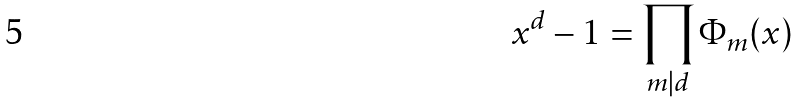Convert formula to latex. <formula><loc_0><loc_0><loc_500><loc_500>x ^ { d } - 1 = \prod _ { m | d } \Phi _ { m } ( x )</formula> 